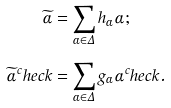Convert formula to latex. <formula><loc_0><loc_0><loc_500><loc_500>\widetilde { \alpha } & = \sum _ { \alpha \in \Delta } h _ { \alpha } \alpha ; \\ \widetilde { \alpha } ^ { c } h e c k & = \sum _ { \alpha \in \Delta } g _ { \alpha } \alpha ^ { c } h e c k .</formula> 